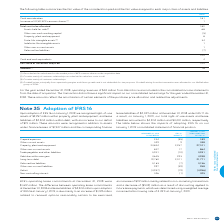According to Bce's financial document, How much right-of-use assets was recognized upon adoption of IFRS 16 on January 1, 2019? $2,257 million within property, plant and equipment. The document states: "uary 1, 2019, we recognized right-of-use assets of $2,257 million within property, plant and equipment, and lease liabilities of $2,304 million within..." Also, What is the weighted average incremental borrowing rate used in 2019? According to the financial document, 3.49%. The relevant text states: "g a weighted average incremental borrowing rate of 3.49% at January 1, 2019...." Also, What was recognized upon adoption of IFRS 16 in 2019? The document shows two values: right-of-use assets and lease liabilities. From the document: "million within property, plant and equipment, and lease liabilities of $2,304 million within debt, with an increase to our deficit of $19 million. The..." Also, How many components had a positive value of IFRS 16 Impacts? Counting the relevant items in the document: Other current assets, Property, plant and equipment, Other non-current assets, Debt due within one year, Long-term debt, I find 5 instances. The key data points involved are: Debt due within one year, Long-term debt, Other current assets. Also, can you calculate: What is the difference between the right-of-use assets recognized within property, plant and equipment and the lease liabilities recognized within debt upon adoption of IFRS 16? Based on the calculation: $2,304 million - $2,257 million , the result is 47 (in millions). This is based on the information: "ry 1, 2019, we recognized right-of-use assets of $2,257 million within property, plant and equipment, and lease liabilities of $2,304 million within debt, y, plant and equipment, and lease liabilities..." The key data points involved are: 2,257, 2,304. Also, can you calculate: What is the percentage change in property, plant and equipment upon adoption of IFRS 16? To answer this question, I need to perform calculations using the financial data. The calculation is: (27,101-24,844)/24,844, which equals 9.08 (percentage). This is based on the information: "Property, plant and equipment 24,844 2,257 27,101 Property, plant and equipment 24,844 2,257 27,101..." The key data points involved are: 24,844, 27,101. 